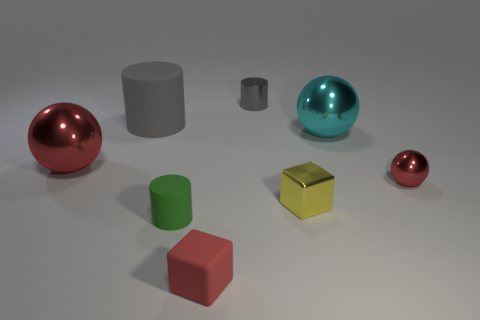Subtract all red metallic spheres. How many spheres are left? 1 Add 2 large brown matte objects. How many objects exist? 10 Subtract all purple balls. Subtract all brown cubes. How many balls are left? 3 Subtract all spheres. How many objects are left? 5 Subtract 0 yellow balls. How many objects are left? 8 Subtract all tiny matte things. Subtract all yellow metal cubes. How many objects are left? 5 Add 5 tiny gray objects. How many tiny gray objects are left? 6 Add 5 yellow things. How many yellow things exist? 6 